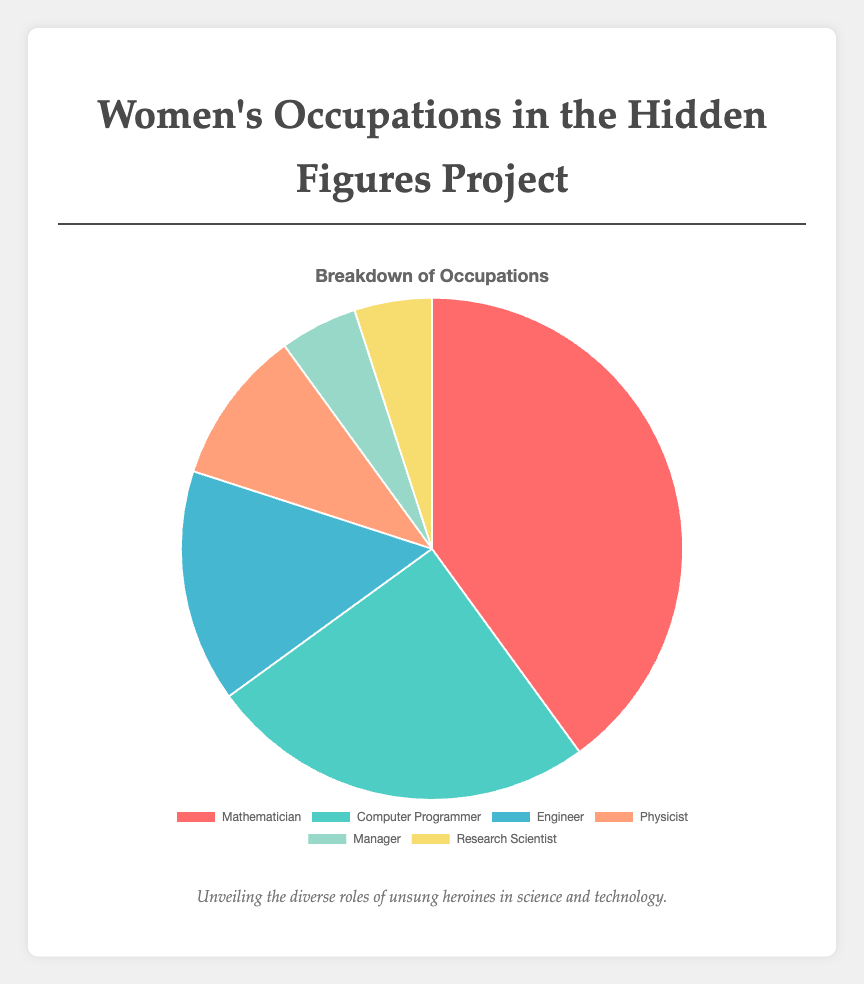Which occupation is the most prevalent within the Hidden Figures project? From the data, the occupation with the highest percentage is "Mathematician", at 40%.
Answer: Mathematician What is the combined percentage of women working as Engineers and Physicists? Sum the percentages of Engineers (15%) and Physicists (10%), giving a total of 15 + 10 = 25%.
Answer: 25% By what percentage do Mathematicians surpass Computer Programmers? Subtract the percentage of Computer Programmers (25%) from Mathematicians (40%), resulting in a difference of 40 - 25 = 15%.
Answer: 15% Which occupation held by women is the least common in the Hidden Figures project? The least common occupations, both at 5%, are "Manager" and "Research Scientist".
Answer: Manager and Research Scientist What is the percentage difference between the occupations of Computer Programmer and Engineer? Subtract the percentage of Engineers (15%) from Computer Programmers (25%), giving a result of 25 - 15 = 10%.
Answer: 10% What is the total percentage of women occupying the roles of Mathematicians, Engineers, and Research Scientists combined? Sum the percentages of Mathematicians (40%), Engineers (15%), and Research Scientists (5%), resulting in 40 + 15 + 5 = 60%.
Answer: 60% Which occupations have the same percentage representation in the Hidden Figures project? Both "Manager" and "Research Scientist" occupations have a percentage representation of 5%.
Answer: Manager and Research Scientist How does the percentage of women in managerial roles compare to that in physicist roles? Women in managerial roles represent 5%, while those in physicist roles represent 10%. Therefore, physicists exceed managers by 10 - 5 = 5%.
Answer: Physicists have 5% more What is the average percentage of women in the listed occupations? Add the percentages of all occupations: (40 + 25 + 15 + 10 + 5 + 5) = 100, then divide by the number of occupations (6), giving an average of 100 / 6 ≈ 16.67%.
Answer: 16.67% What proportion of the chart is occupied by non-Mathematician roles? Subtract the percentage of Mathematicians (40%) from 100%, giving 100 - 40 = 60%.
Answer: 60% 